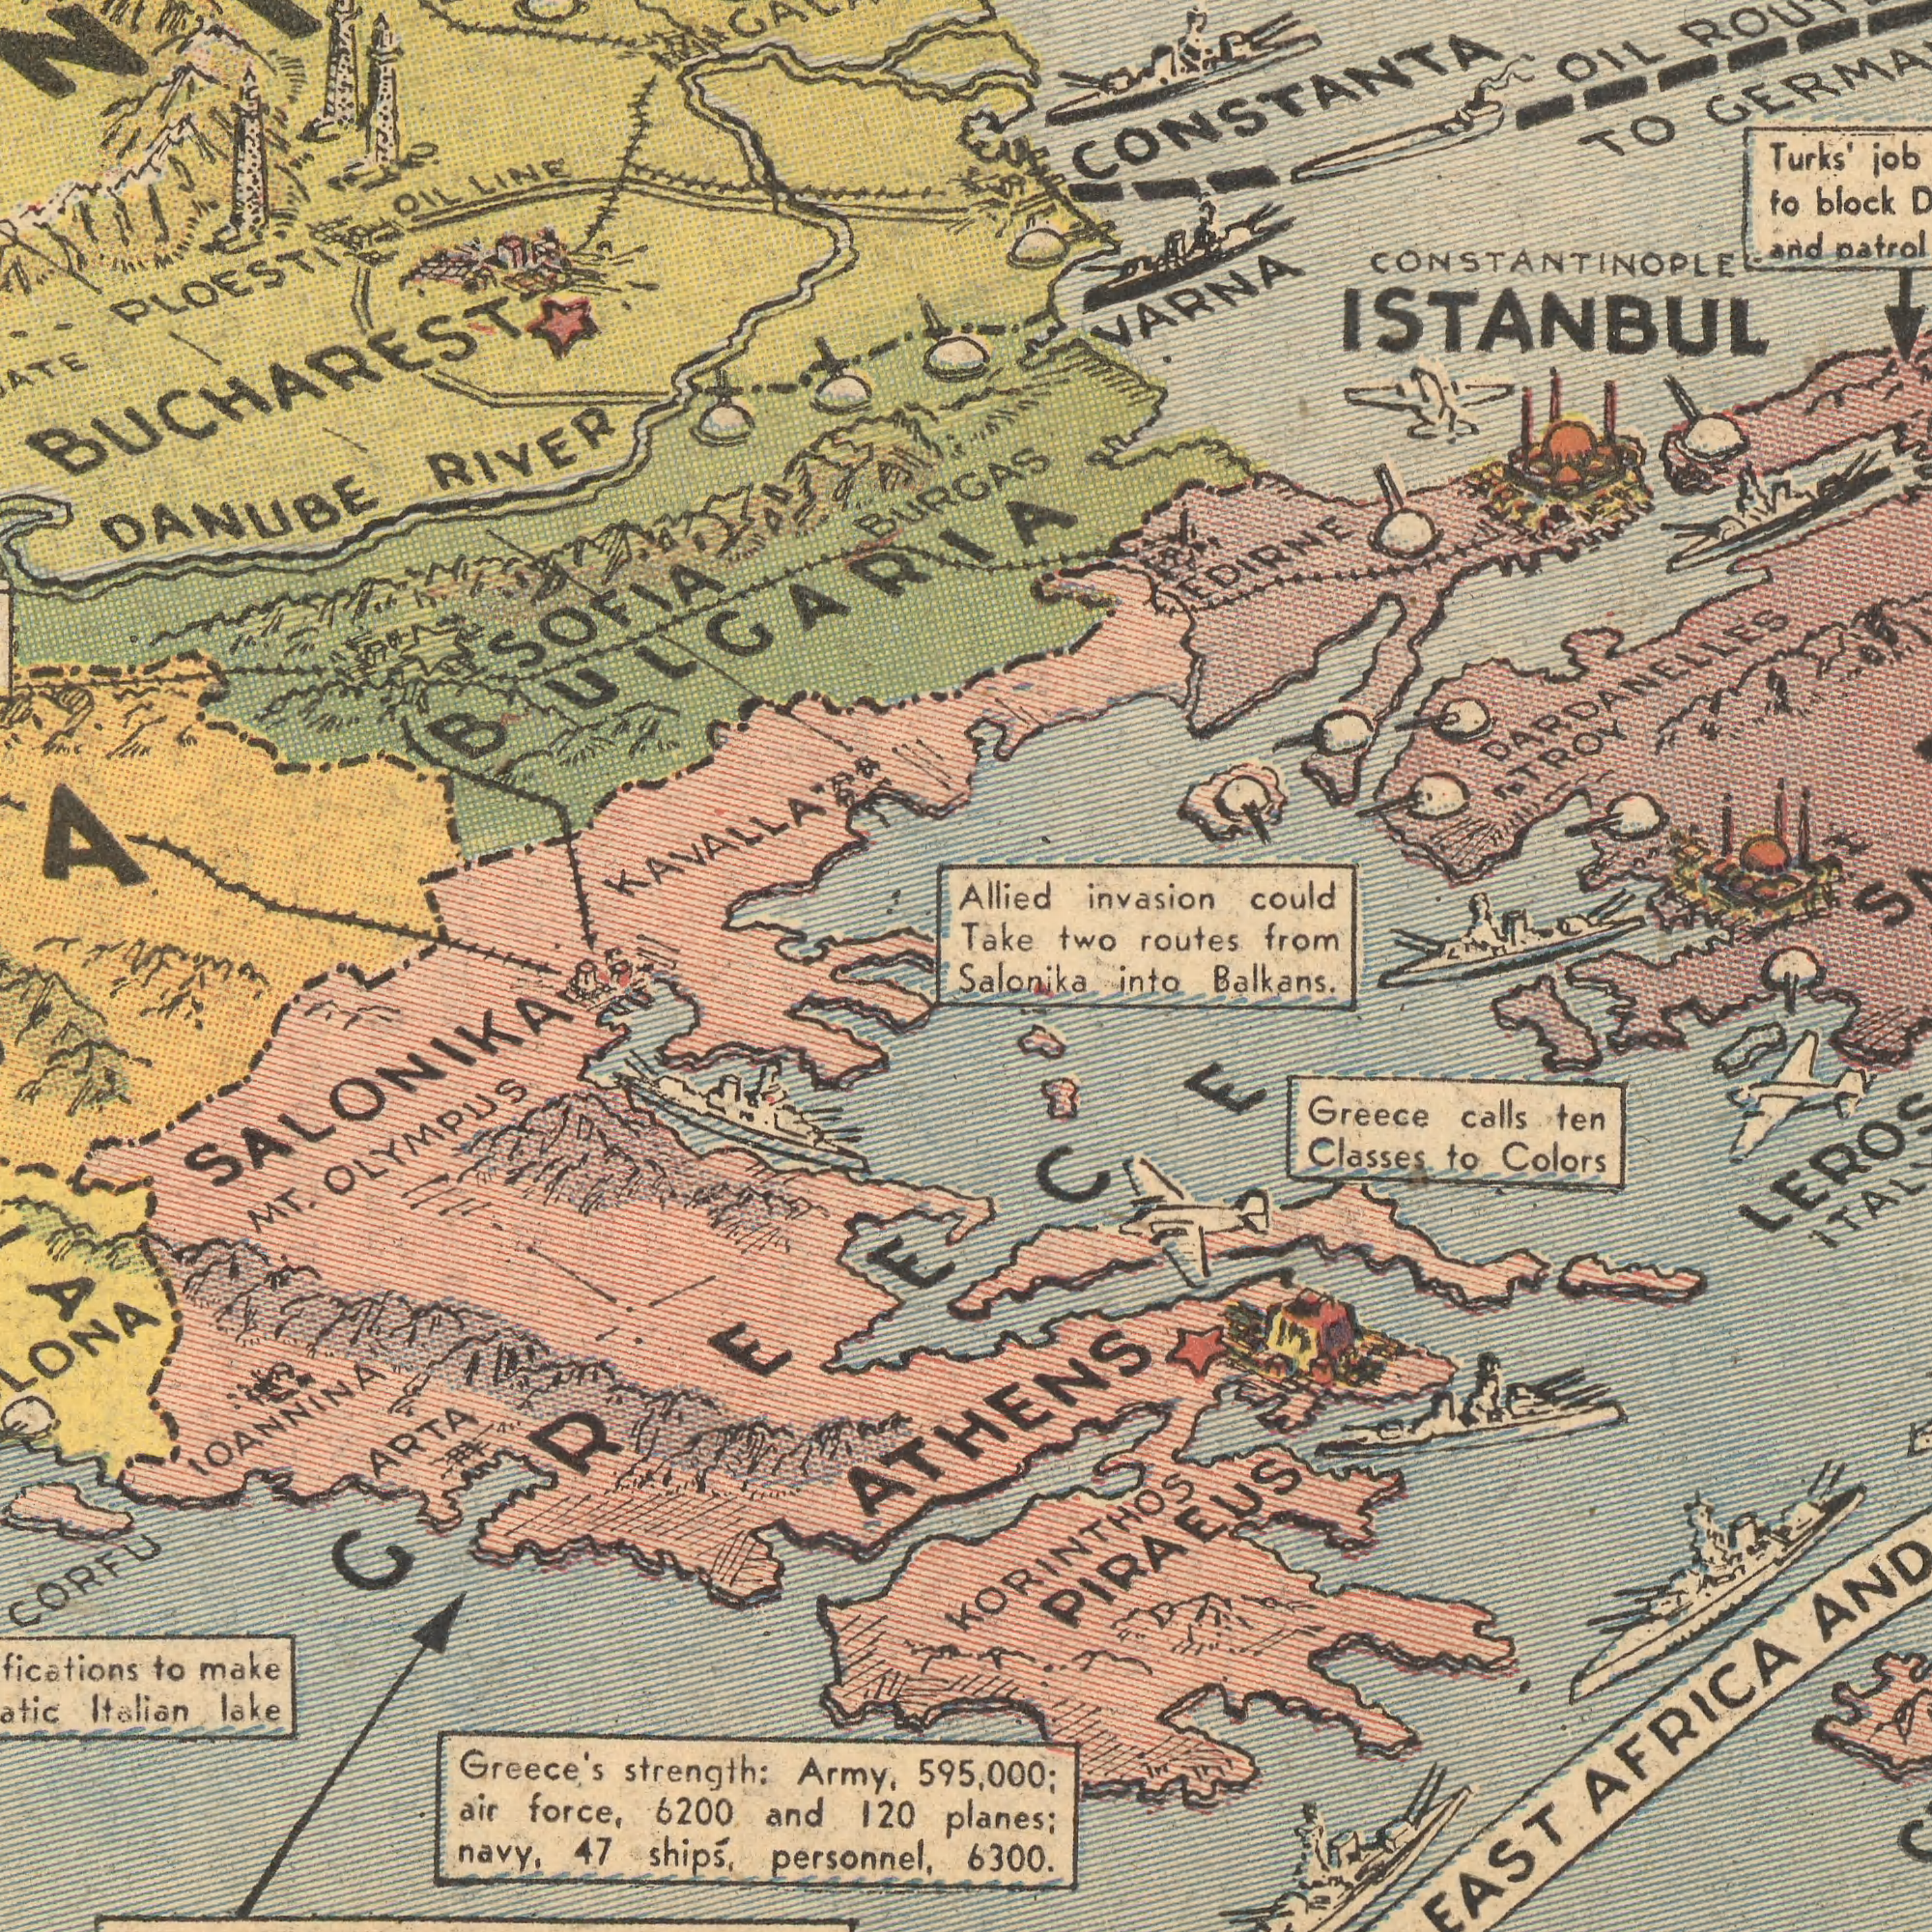What text can you see in the top-left section? DANUBE RIVER SOFIA BULGARIA OIL LINE KAVALLA BURGAS PLOESTI BUCHAREST What text appears in the bottom-left area of the image? Greece's strength: Army, air force, 6200 and 120 navy, 47 shipÅ›, personnel, to make Italian lake CORFU MT. OLYMPUS IOANNINA ARTA SALONIKA GREECE What text appears in the bottom-right area of the image? Salonika into Balkans. 595,000; planes; 6300. ATHENS Greece calls ten Classes to Colors AFRICA PIRAEUS KORINTHOS What text is shown in the top-right quadrant? Allied invasion could Take two routes from Turks' job to block and patrol VARNA OIL TO CONSTANTINOPLE ISTANBUL EDIRNE DARDANELLES TROY CONSTANTA 